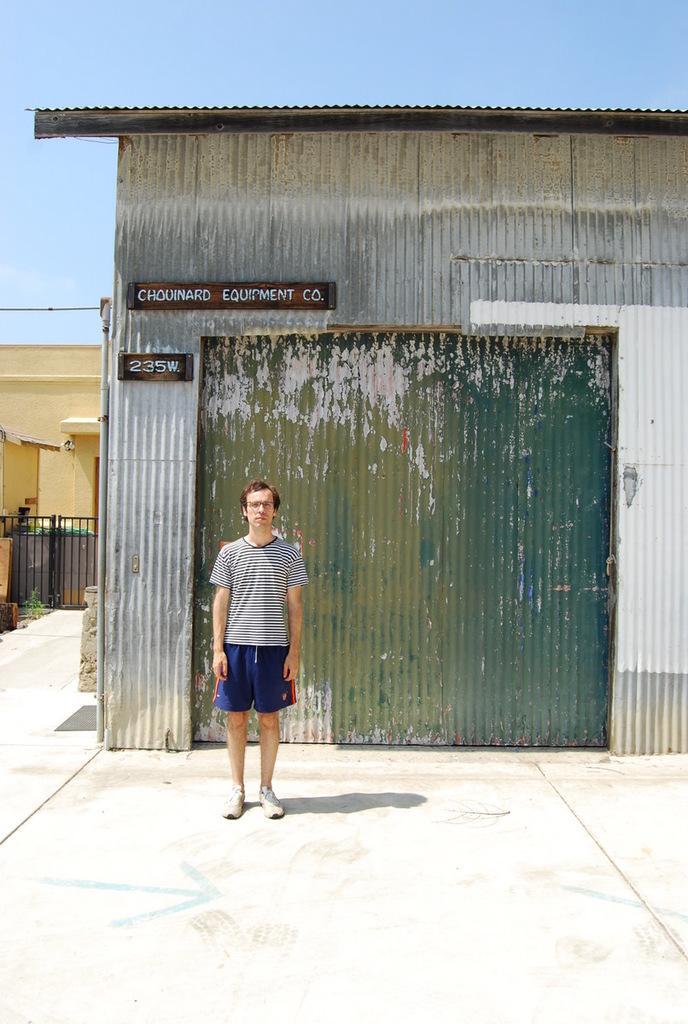Please provide a concise description of this image. This is an outside view. Here I can see a man standing on the floor and giving pose for the picture. At the back of him there is a shed and there are two boards attached to it. On the boards I can see some text. On the left side there is a building and also I can see the gate. At the top of the image I can see the sky. 